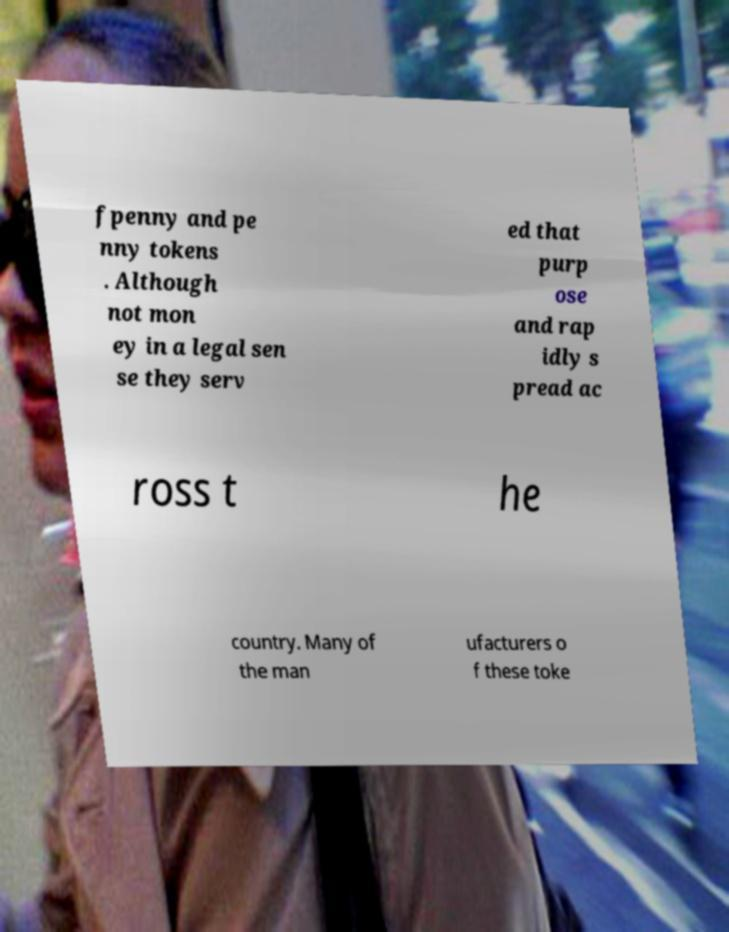There's text embedded in this image that I need extracted. Can you transcribe it verbatim? fpenny and pe nny tokens . Although not mon ey in a legal sen se they serv ed that purp ose and rap idly s pread ac ross t he country. Many of the man ufacturers o f these toke 